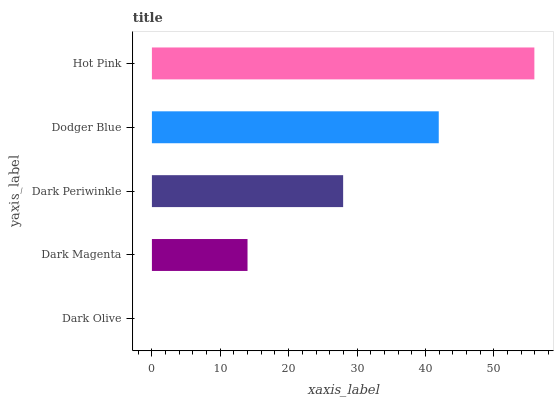Is Dark Olive the minimum?
Answer yes or no. Yes. Is Hot Pink the maximum?
Answer yes or no. Yes. Is Dark Magenta the minimum?
Answer yes or no. No. Is Dark Magenta the maximum?
Answer yes or no. No. Is Dark Magenta greater than Dark Olive?
Answer yes or no. Yes. Is Dark Olive less than Dark Magenta?
Answer yes or no. Yes. Is Dark Olive greater than Dark Magenta?
Answer yes or no. No. Is Dark Magenta less than Dark Olive?
Answer yes or no. No. Is Dark Periwinkle the high median?
Answer yes or no. Yes. Is Dark Periwinkle the low median?
Answer yes or no. Yes. Is Dark Olive the high median?
Answer yes or no. No. Is Dark Magenta the low median?
Answer yes or no. No. 